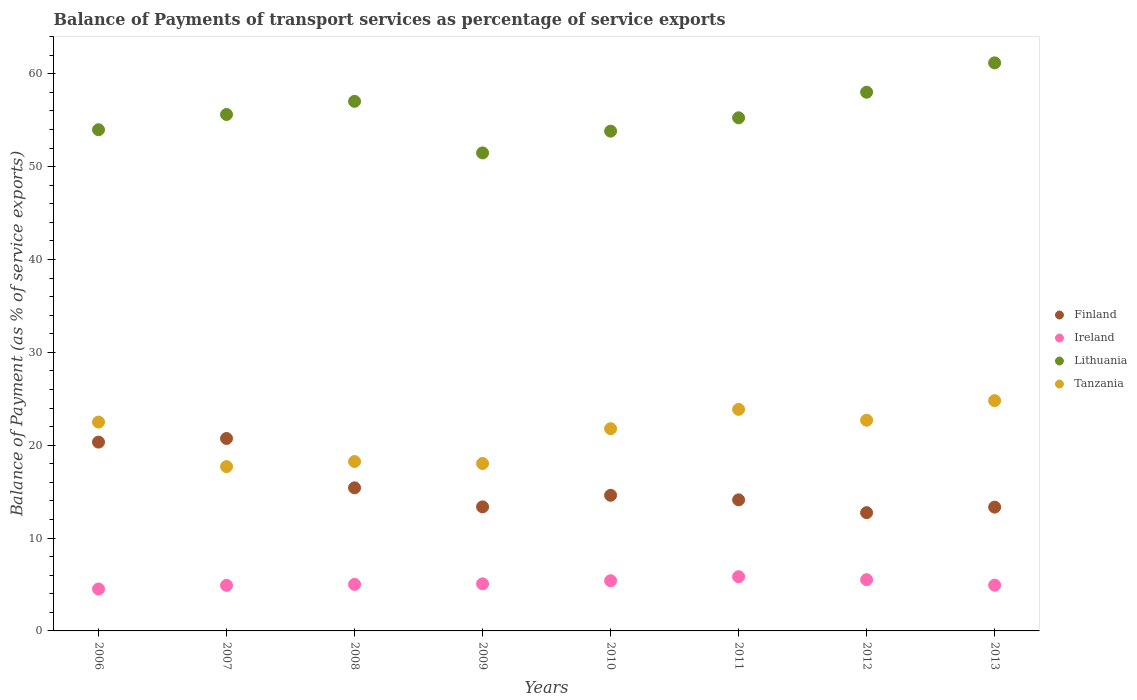How many different coloured dotlines are there?
Keep it short and to the point. 4. Is the number of dotlines equal to the number of legend labels?
Your response must be concise. Yes. What is the balance of payments of transport services in Finland in 2013?
Your answer should be very brief. 13.33. Across all years, what is the maximum balance of payments of transport services in Ireland?
Your answer should be compact. 5.84. Across all years, what is the minimum balance of payments of transport services in Finland?
Provide a succinct answer. 12.73. In which year was the balance of payments of transport services in Tanzania maximum?
Provide a succinct answer. 2013. What is the total balance of payments of transport services in Tanzania in the graph?
Your answer should be compact. 169.59. What is the difference between the balance of payments of transport services in Ireland in 2011 and that in 2013?
Ensure brevity in your answer.  0.91. What is the difference between the balance of payments of transport services in Finland in 2011 and the balance of payments of transport services in Tanzania in 2007?
Your response must be concise. -3.58. What is the average balance of payments of transport services in Finland per year?
Your response must be concise. 15.58. In the year 2007, what is the difference between the balance of payments of transport services in Finland and balance of payments of transport services in Ireland?
Offer a very short reply. 15.82. What is the ratio of the balance of payments of transport services in Ireland in 2007 to that in 2012?
Offer a terse response. 0.89. Is the difference between the balance of payments of transport services in Finland in 2008 and 2013 greater than the difference between the balance of payments of transport services in Ireland in 2008 and 2013?
Ensure brevity in your answer.  Yes. What is the difference between the highest and the second highest balance of payments of transport services in Tanzania?
Give a very brief answer. 0.94. What is the difference between the highest and the lowest balance of payments of transport services in Finland?
Your answer should be very brief. 7.99. How many dotlines are there?
Give a very brief answer. 4. What is the difference between two consecutive major ticks on the Y-axis?
Your answer should be compact. 10. Where does the legend appear in the graph?
Your answer should be very brief. Center right. What is the title of the graph?
Your response must be concise. Balance of Payments of transport services as percentage of service exports. What is the label or title of the X-axis?
Provide a succinct answer. Years. What is the label or title of the Y-axis?
Ensure brevity in your answer.  Balance of Payment (as % of service exports). What is the Balance of Payment (as % of service exports) of Finland in 2006?
Provide a short and direct response. 20.33. What is the Balance of Payment (as % of service exports) of Ireland in 2006?
Your answer should be compact. 4.52. What is the Balance of Payment (as % of service exports) in Lithuania in 2006?
Ensure brevity in your answer.  53.97. What is the Balance of Payment (as % of service exports) in Tanzania in 2006?
Provide a short and direct response. 22.49. What is the Balance of Payment (as % of service exports) in Finland in 2007?
Offer a terse response. 20.72. What is the Balance of Payment (as % of service exports) in Ireland in 2007?
Your response must be concise. 4.91. What is the Balance of Payment (as % of service exports) of Lithuania in 2007?
Ensure brevity in your answer.  55.62. What is the Balance of Payment (as % of service exports) in Tanzania in 2007?
Make the answer very short. 17.7. What is the Balance of Payment (as % of service exports) in Finland in 2008?
Provide a succinct answer. 15.41. What is the Balance of Payment (as % of service exports) of Ireland in 2008?
Give a very brief answer. 5.01. What is the Balance of Payment (as % of service exports) of Lithuania in 2008?
Make the answer very short. 57.03. What is the Balance of Payment (as % of service exports) of Tanzania in 2008?
Provide a succinct answer. 18.24. What is the Balance of Payment (as % of service exports) of Finland in 2009?
Keep it short and to the point. 13.36. What is the Balance of Payment (as % of service exports) in Ireland in 2009?
Your answer should be compact. 5.07. What is the Balance of Payment (as % of service exports) in Lithuania in 2009?
Provide a short and direct response. 51.48. What is the Balance of Payment (as % of service exports) of Tanzania in 2009?
Ensure brevity in your answer.  18.03. What is the Balance of Payment (as % of service exports) in Finland in 2010?
Your response must be concise. 14.61. What is the Balance of Payment (as % of service exports) of Ireland in 2010?
Your response must be concise. 5.4. What is the Balance of Payment (as % of service exports) in Lithuania in 2010?
Offer a terse response. 53.82. What is the Balance of Payment (as % of service exports) in Tanzania in 2010?
Keep it short and to the point. 21.78. What is the Balance of Payment (as % of service exports) in Finland in 2011?
Provide a succinct answer. 14.12. What is the Balance of Payment (as % of service exports) in Ireland in 2011?
Offer a terse response. 5.84. What is the Balance of Payment (as % of service exports) of Lithuania in 2011?
Provide a succinct answer. 55.26. What is the Balance of Payment (as % of service exports) in Tanzania in 2011?
Make the answer very short. 23.86. What is the Balance of Payment (as % of service exports) in Finland in 2012?
Give a very brief answer. 12.73. What is the Balance of Payment (as % of service exports) in Ireland in 2012?
Provide a succinct answer. 5.52. What is the Balance of Payment (as % of service exports) of Lithuania in 2012?
Provide a short and direct response. 58.01. What is the Balance of Payment (as % of service exports) of Tanzania in 2012?
Make the answer very short. 22.69. What is the Balance of Payment (as % of service exports) in Finland in 2013?
Ensure brevity in your answer.  13.33. What is the Balance of Payment (as % of service exports) in Ireland in 2013?
Your answer should be very brief. 4.93. What is the Balance of Payment (as % of service exports) in Lithuania in 2013?
Offer a terse response. 61.17. What is the Balance of Payment (as % of service exports) in Tanzania in 2013?
Ensure brevity in your answer.  24.8. Across all years, what is the maximum Balance of Payment (as % of service exports) of Finland?
Make the answer very short. 20.72. Across all years, what is the maximum Balance of Payment (as % of service exports) of Ireland?
Provide a short and direct response. 5.84. Across all years, what is the maximum Balance of Payment (as % of service exports) in Lithuania?
Your response must be concise. 61.17. Across all years, what is the maximum Balance of Payment (as % of service exports) in Tanzania?
Keep it short and to the point. 24.8. Across all years, what is the minimum Balance of Payment (as % of service exports) of Finland?
Your answer should be very brief. 12.73. Across all years, what is the minimum Balance of Payment (as % of service exports) in Ireland?
Offer a very short reply. 4.52. Across all years, what is the minimum Balance of Payment (as % of service exports) in Lithuania?
Your answer should be very brief. 51.48. Across all years, what is the minimum Balance of Payment (as % of service exports) of Tanzania?
Ensure brevity in your answer.  17.7. What is the total Balance of Payment (as % of service exports) of Finland in the graph?
Give a very brief answer. 124.62. What is the total Balance of Payment (as % of service exports) of Ireland in the graph?
Your answer should be compact. 41.2. What is the total Balance of Payment (as % of service exports) of Lithuania in the graph?
Provide a succinct answer. 446.37. What is the total Balance of Payment (as % of service exports) in Tanzania in the graph?
Your answer should be very brief. 169.59. What is the difference between the Balance of Payment (as % of service exports) of Finland in 2006 and that in 2007?
Provide a short and direct response. -0.39. What is the difference between the Balance of Payment (as % of service exports) in Ireland in 2006 and that in 2007?
Your response must be concise. -0.39. What is the difference between the Balance of Payment (as % of service exports) of Lithuania in 2006 and that in 2007?
Make the answer very short. -1.64. What is the difference between the Balance of Payment (as % of service exports) in Tanzania in 2006 and that in 2007?
Provide a short and direct response. 4.8. What is the difference between the Balance of Payment (as % of service exports) of Finland in 2006 and that in 2008?
Offer a very short reply. 4.92. What is the difference between the Balance of Payment (as % of service exports) in Ireland in 2006 and that in 2008?
Make the answer very short. -0.5. What is the difference between the Balance of Payment (as % of service exports) of Lithuania in 2006 and that in 2008?
Provide a succinct answer. -3.06. What is the difference between the Balance of Payment (as % of service exports) in Tanzania in 2006 and that in 2008?
Provide a succinct answer. 4.25. What is the difference between the Balance of Payment (as % of service exports) of Finland in 2006 and that in 2009?
Give a very brief answer. 6.98. What is the difference between the Balance of Payment (as % of service exports) in Ireland in 2006 and that in 2009?
Your answer should be compact. -0.56. What is the difference between the Balance of Payment (as % of service exports) of Lithuania in 2006 and that in 2009?
Ensure brevity in your answer.  2.5. What is the difference between the Balance of Payment (as % of service exports) of Tanzania in 2006 and that in 2009?
Provide a short and direct response. 4.46. What is the difference between the Balance of Payment (as % of service exports) of Finland in 2006 and that in 2010?
Offer a terse response. 5.73. What is the difference between the Balance of Payment (as % of service exports) in Ireland in 2006 and that in 2010?
Your answer should be very brief. -0.89. What is the difference between the Balance of Payment (as % of service exports) of Lithuania in 2006 and that in 2010?
Provide a short and direct response. 0.15. What is the difference between the Balance of Payment (as % of service exports) of Tanzania in 2006 and that in 2010?
Your answer should be compact. 0.72. What is the difference between the Balance of Payment (as % of service exports) in Finland in 2006 and that in 2011?
Your answer should be compact. 6.22. What is the difference between the Balance of Payment (as % of service exports) of Ireland in 2006 and that in 2011?
Your response must be concise. -1.33. What is the difference between the Balance of Payment (as % of service exports) of Lithuania in 2006 and that in 2011?
Your response must be concise. -1.29. What is the difference between the Balance of Payment (as % of service exports) in Tanzania in 2006 and that in 2011?
Provide a succinct answer. -1.37. What is the difference between the Balance of Payment (as % of service exports) in Finland in 2006 and that in 2012?
Your answer should be very brief. 7.6. What is the difference between the Balance of Payment (as % of service exports) of Ireland in 2006 and that in 2012?
Your answer should be compact. -1. What is the difference between the Balance of Payment (as % of service exports) of Lithuania in 2006 and that in 2012?
Ensure brevity in your answer.  -4.04. What is the difference between the Balance of Payment (as % of service exports) in Tanzania in 2006 and that in 2012?
Offer a terse response. -0.2. What is the difference between the Balance of Payment (as % of service exports) of Finland in 2006 and that in 2013?
Give a very brief answer. 7. What is the difference between the Balance of Payment (as % of service exports) in Ireland in 2006 and that in 2013?
Your answer should be very brief. -0.41. What is the difference between the Balance of Payment (as % of service exports) of Lithuania in 2006 and that in 2013?
Offer a very short reply. -7.2. What is the difference between the Balance of Payment (as % of service exports) of Tanzania in 2006 and that in 2013?
Make the answer very short. -2.3. What is the difference between the Balance of Payment (as % of service exports) in Finland in 2007 and that in 2008?
Your response must be concise. 5.31. What is the difference between the Balance of Payment (as % of service exports) of Ireland in 2007 and that in 2008?
Your response must be concise. -0.1. What is the difference between the Balance of Payment (as % of service exports) in Lithuania in 2007 and that in 2008?
Keep it short and to the point. -1.41. What is the difference between the Balance of Payment (as % of service exports) in Tanzania in 2007 and that in 2008?
Offer a very short reply. -0.55. What is the difference between the Balance of Payment (as % of service exports) in Finland in 2007 and that in 2009?
Offer a very short reply. 7.37. What is the difference between the Balance of Payment (as % of service exports) of Ireland in 2007 and that in 2009?
Ensure brevity in your answer.  -0.16. What is the difference between the Balance of Payment (as % of service exports) of Lithuania in 2007 and that in 2009?
Your answer should be compact. 4.14. What is the difference between the Balance of Payment (as % of service exports) in Tanzania in 2007 and that in 2009?
Make the answer very short. -0.33. What is the difference between the Balance of Payment (as % of service exports) in Finland in 2007 and that in 2010?
Your answer should be very brief. 6.12. What is the difference between the Balance of Payment (as % of service exports) in Ireland in 2007 and that in 2010?
Provide a short and direct response. -0.5. What is the difference between the Balance of Payment (as % of service exports) of Lithuania in 2007 and that in 2010?
Your answer should be compact. 1.79. What is the difference between the Balance of Payment (as % of service exports) in Tanzania in 2007 and that in 2010?
Offer a very short reply. -4.08. What is the difference between the Balance of Payment (as % of service exports) in Finland in 2007 and that in 2011?
Your response must be concise. 6.61. What is the difference between the Balance of Payment (as % of service exports) in Ireland in 2007 and that in 2011?
Your response must be concise. -0.93. What is the difference between the Balance of Payment (as % of service exports) in Lithuania in 2007 and that in 2011?
Offer a terse response. 0.36. What is the difference between the Balance of Payment (as % of service exports) in Tanzania in 2007 and that in 2011?
Your answer should be very brief. -6.16. What is the difference between the Balance of Payment (as % of service exports) in Finland in 2007 and that in 2012?
Give a very brief answer. 7.99. What is the difference between the Balance of Payment (as % of service exports) in Ireland in 2007 and that in 2012?
Provide a succinct answer. -0.61. What is the difference between the Balance of Payment (as % of service exports) in Lithuania in 2007 and that in 2012?
Provide a short and direct response. -2.4. What is the difference between the Balance of Payment (as % of service exports) in Tanzania in 2007 and that in 2012?
Offer a terse response. -4.99. What is the difference between the Balance of Payment (as % of service exports) of Finland in 2007 and that in 2013?
Ensure brevity in your answer.  7.39. What is the difference between the Balance of Payment (as % of service exports) in Ireland in 2007 and that in 2013?
Your response must be concise. -0.02. What is the difference between the Balance of Payment (as % of service exports) of Lithuania in 2007 and that in 2013?
Provide a succinct answer. -5.56. What is the difference between the Balance of Payment (as % of service exports) in Tanzania in 2007 and that in 2013?
Offer a terse response. -7.1. What is the difference between the Balance of Payment (as % of service exports) of Finland in 2008 and that in 2009?
Keep it short and to the point. 2.05. What is the difference between the Balance of Payment (as % of service exports) in Ireland in 2008 and that in 2009?
Your answer should be compact. -0.06. What is the difference between the Balance of Payment (as % of service exports) in Lithuania in 2008 and that in 2009?
Give a very brief answer. 5.56. What is the difference between the Balance of Payment (as % of service exports) in Tanzania in 2008 and that in 2009?
Your answer should be very brief. 0.21. What is the difference between the Balance of Payment (as % of service exports) of Finland in 2008 and that in 2010?
Your response must be concise. 0.8. What is the difference between the Balance of Payment (as % of service exports) in Ireland in 2008 and that in 2010?
Provide a succinct answer. -0.39. What is the difference between the Balance of Payment (as % of service exports) of Lithuania in 2008 and that in 2010?
Ensure brevity in your answer.  3.21. What is the difference between the Balance of Payment (as % of service exports) in Tanzania in 2008 and that in 2010?
Offer a very short reply. -3.53. What is the difference between the Balance of Payment (as % of service exports) in Finland in 2008 and that in 2011?
Provide a succinct answer. 1.29. What is the difference between the Balance of Payment (as % of service exports) of Ireland in 2008 and that in 2011?
Make the answer very short. -0.83. What is the difference between the Balance of Payment (as % of service exports) in Lithuania in 2008 and that in 2011?
Make the answer very short. 1.77. What is the difference between the Balance of Payment (as % of service exports) of Tanzania in 2008 and that in 2011?
Keep it short and to the point. -5.62. What is the difference between the Balance of Payment (as % of service exports) of Finland in 2008 and that in 2012?
Your answer should be very brief. 2.68. What is the difference between the Balance of Payment (as % of service exports) in Ireland in 2008 and that in 2012?
Offer a terse response. -0.51. What is the difference between the Balance of Payment (as % of service exports) of Lithuania in 2008 and that in 2012?
Provide a short and direct response. -0.98. What is the difference between the Balance of Payment (as % of service exports) in Tanzania in 2008 and that in 2012?
Provide a succinct answer. -4.45. What is the difference between the Balance of Payment (as % of service exports) in Finland in 2008 and that in 2013?
Your answer should be very brief. 2.08. What is the difference between the Balance of Payment (as % of service exports) of Ireland in 2008 and that in 2013?
Your response must be concise. 0.09. What is the difference between the Balance of Payment (as % of service exports) in Lithuania in 2008 and that in 2013?
Your answer should be compact. -4.14. What is the difference between the Balance of Payment (as % of service exports) in Tanzania in 2008 and that in 2013?
Provide a succinct answer. -6.55. What is the difference between the Balance of Payment (as % of service exports) of Finland in 2009 and that in 2010?
Keep it short and to the point. -1.25. What is the difference between the Balance of Payment (as % of service exports) in Ireland in 2009 and that in 2010?
Provide a succinct answer. -0.33. What is the difference between the Balance of Payment (as % of service exports) in Lithuania in 2009 and that in 2010?
Make the answer very short. -2.35. What is the difference between the Balance of Payment (as % of service exports) in Tanzania in 2009 and that in 2010?
Provide a succinct answer. -3.75. What is the difference between the Balance of Payment (as % of service exports) of Finland in 2009 and that in 2011?
Provide a short and direct response. -0.76. What is the difference between the Balance of Payment (as % of service exports) in Ireland in 2009 and that in 2011?
Offer a terse response. -0.77. What is the difference between the Balance of Payment (as % of service exports) in Lithuania in 2009 and that in 2011?
Offer a terse response. -3.78. What is the difference between the Balance of Payment (as % of service exports) of Tanzania in 2009 and that in 2011?
Your response must be concise. -5.83. What is the difference between the Balance of Payment (as % of service exports) in Finland in 2009 and that in 2012?
Offer a terse response. 0.62. What is the difference between the Balance of Payment (as % of service exports) in Ireland in 2009 and that in 2012?
Your answer should be very brief. -0.45. What is the difference between the Balance of Payment (as % of service exports) in Lithuania in 2009 and that in 2012?
Your answer should be very brief. -6.54. What is the difference between the Balance of Payment (as % of service exports) of Tanzania in 2009 and that in 2012?
Keep it short and to the point. -4.66. What is the difference between the Balance of Payment (as % of service exports) in Finland in 2009 and that in 2013?
Ensure brevity in your answer.  0.03. What is the difference between the Balance of Payment (as % of service exports) in Ireland in 2009 and that in 2013?
Your response must be concise. 0.14. What is the difference between the Balance of Payment (as % of service exports) in Lithuania in 2009 and that in 2013?
Provide a succinct answer. -9.7. What is the difference between the Balance of Payment (as % of service exports) of Tanzania in 2009 and that in 2013?
Your answer should be very brief. -6.77. What is the difference between the Balance of Payment (as % of service exports) in Finland in 2010 and that in 2011?
Provide a short and direct response. 0.49. What is the difference between the Balance of Payment (as % of service exports) of Ireland in 2010 and that in 2011?
Offer a very short reply. -0.44. What is the difference between the Balance of Payment (as % of service exports) in Lithuania in 2010 and that in 2011?
Ensure brevity in your answer.  -1.44. What is the difference between the Balance of Payment (as % of service exports) in Tanzania in 2010 and that in 2011?
Give a very brief answer. -2.08. What is the difference between the Balance of Payment (as % of service exports) of Finland in 2010 and that in 2012?
Provide a succinct answer. 1.87. What is the difference between the Balance of Payment (as % of service exports) in Ireland in 2010 and that in 2012?
Your answer should be very brief. -0.11. What is the difference between the Balance of Payment (as % of service exports) of Lithuania in 2010 and that in 2012?
Keep it short and to the point. -4.19. What is the difference between the Balance of Payment (as % of service exports) in Tanzania in 2010 and that in 2012?
Keep it short and to the point. -0.91. What is the difference between the Balance of Payment (as % of service exports) in Finland in 2010 and that in 2013?
Your answer should be very brief. 1.28. What is the difference between the Balance of Payment (as % of service exports) of Ireland in 2010 and that in 2013?
Make the answer very short. 0.48. What is the difference between the Balance of Payment (as % of service exports) of Lithuania in 2010 and that in 2013?
Offer a very short reply. -7.35. What is the difference between the Balance of Payment (as % of service exports) of Tanzania in 2010 and that in 2013?
Your response must be concise. -3.02. What is the difference between the Balance of Payment (as % of service exports) of Finland in 2011 and that in 2012?
Provide a succinct answer. 1.38. What is the difference between the Balance of Payment (as % of service exports) of Ireland in 2011 and that in 2012?
Provide a short and direct response. 0.32. What is the difference between the Balance of Payment (as % of service exports) of Lithuania in 2011 and that in 2012?
Offer a terse response. -2.76. What is the difference between the Balance of Payment (as % of service exports) of Tanzania in 2011 and that in 2012?
Offer a very short reply. 1.17. What is the difference between the Balance of Payment (as % of service exports) in Finland in 2011 and that in 2013?
Provide a short and direct response. 0.78. What is the difference between the Balance of Payment (as % of service exports) in Ireland in 2011 and that in 2013?
Make the answer very short. 0.91. What is the difference between the Balance of Payment (as % of service exports) in Lithuania in 2011 and that in 2013?
Offer a very short reply. -5.91. What is the difference between the Balance of Payment (as % of service exports) of Tanzania in 2011 and that in 2013?
Provide a short and direct response. -0.94. What is the difference between the Balance of Payment (as % of service exports) in Finland in 2012 and that in 2013?
Give a very brief answer. -0.6. What is the difference between the Balance of Payment (as % of service exports) of Ireland in 2012 and that in 2013?
Your answer should be compact. 0.59. What is the difference between the Balance of Payment (as % of service exports) of Lithuania in 2012 and that in 2013?
Provide a succinct answer. -3.16. What is the difference between the Balance of Payment (as % of service exports) in Tanzania in 2012 and that in 2013?
Keep it short and to the point. -2.11. What is the difference between the Balance of Payment (as % of service exports) in Finland in 2006 and the Balance of Payment (as % of service exports) in Ireland in 2007?
Offer a terse response. 15.43. What is the difference between the Balance of Payment (as % of service exports) of Finland in 2006 and the Balance of Payment (as % of service exports) of Lithuania in 2007?
Your answer should be very brief. -35.28. What is the difference between the Balance of Payment (as % of service exports) of Finland in 2006 and the Balance of Payment (as % of service exports) of Tanzania in 2007?
Make the answer very short. 2.64. What is the difference between the Balance of Payment (as % of service exports) of Ireland in 2006 and the Balance of Payment (as % of service exports) of Lithuania in 2007?
Provide a short and direct response. -51.1. What is the difference between the Balance of Payment (as % of service exports) of Ireland in 2006 and the Balance of Payment (as % of service exports) of Tanzania in 2007?
Offer a terse response. -13.18. What is the difference between the Balance of Payment (as % of service exports) of Lithuania in 2006 and the Balance of Payment (as % of service exports) of Tanzania in 2007?
Provide a short and direct response. 36.28. What is the difference between the Balance of Payment (as % of service exports) of Finland in 2006 and the Balance of Payment (as % of service exports) of Ireland in 2008?
Give a very brief answer. 15.32. What is the difference between the Balance of Payment (as % of service exports) of Finland in 2006 and the Balance of Payment (as % of service exports) of Lithuania in 2008?
Offer a very short reply. -36.7. What is the difference between the Balance of Payment (as % of service exports) of Finland in 2006 and the Balance of Payment (as % of service exports) of Tanzania in 2008?
Make the answer very short. 2.09. What is the difference between the Balance of Payment (as % of service exports) in Ireland in 2006 and the Balance of Payment (as % of service exports) in Lithuania in 2008?
Give a very brief answer. -52.52. What is the difference between the Balance of Payment (as % of service exports) in Ireland in 2006 and the Balance of Payment (as % of service exports) in Tanzania in 2008?
Your answer should be compact. -13.73. What is the difference between the Balance of Payment (as % of service exports) of Lithuania in 2006 and the Balance of Payment (as % of service exports) of Tanzania in 2008?
Make the answer very short. 35.73. What is the difference between the Balance of Payment (as % of service exports) in Finland in 2006 and the Balance of Payment (as % of service exports) in Ireland in 2009?
Offer a very short reply. 15.26. What is the difference between the Balance of Payment (as % of service exports) of Finland in 2006 and the Balance of Payment (as % of service exports) of Lithuania in 2009?
Your answer should be very brief. -31.14. What is the difference between the Balance of Payment (as % of service exports) of Finland in 2006 and the Balance of Payment (as % of service exports) of Tanzania in 2009?
Offer a very short reply. 2.3. What is the difference between the Balance of Payment (as % of service exports) of Ireland in 2006 and the Balance of Payment (as % of service exports) of Lithuania in 2009?
Your answer should be very brief. -46.96. What is the difference between the Balance of Payment (as % of service exports) of Ireland in 2006 and the Balance of Payment (as % of service exports) of Tanzania in 2009?
Offer a very short reply. -13.52. What is the difference between the Balance of Payment (as % of service exports) in Lithuania in 2006 and the Balance of Payment (as % of service exports) in Tanzania in 2009?
Make the answer very short. 35.94. What is the difference between the Balance of Payment (as % of service exports) in Finland in 2006 and the Balance of Payment (as % of service exports) in Ireland in 2010?
Give a very brief answer. 14.93. What is the difference between the Balance of Payment (as % of service exports) in Finland in 2006 and the Balance of Payment (as % of service exports) in Lithuania in 2010?
Keep it short and to the point. -33.49. What is the difference between the Balance of Payment (as % of service exports) of Finland in 2006 and the Balance of Payment (as % of service exports) of Tanzania in 2010?
Your answer should be compact. -1.44. What is the difference between the Balance of Payment (as % of service exports) of Ireland in 2006 and the Balance of Payment (as % of service exports) of Lithuania in 2010?
Offer a very short reply. -49.31. What is the difference between the Balance of Payment (as % of service exports) in Ireland in 2006 and the Balance of Payment (as % of service exports) in Tanzania in 2010?
Make the answer very short. -17.26. What is the difference between the Balance of Payment (as % of service exports) in Lithuania in 2006 and the Balance of Payment (as % of service exports) in Tanzania in 2010?
Keep it short and to the point. 32.2. What is the difference between the Balance of Payment (as % of service exports) of Finland in 2006 and the Balance of Payment (as % of service exports) of Ireland in 2011?
Provide a short and direct response. 14.49. What is the difference between the Balance of Payment (as % of service exports) of Finland in 2006 and the Balance of Payment (as % of service exports) of Lithuania in 2011?
Give a very brief answer. -34.92. What is the difference between the Balance of Payment (as % of service exports) of Finland in 2006 and the Balance of Payment (as % of service exports) of Tanzania in 2011?
Make the answer very short. -3.52. What is the difference between the Balance of Payment (as % of service exports) of Ireland in 2006 and the Balance of Payment (as % of service exports) of Lithuania in 2011?
Keep it short and to the point. -50.74. What is the difference between the Balance of Payment (as % of service exports) of Ireland in 2006 and the Balance of Payment (as % of service exports) of Tanzania in 2011?
Your answer should be very brief. -19.34. What is the difference between the Balance of Payment (as % of service exports) in Lithuania in 2006 and the Balance of Payment (as % of service exports) in Tanzania in 2011?
Your answer should be very brief. 30.11. What is the difference between the Balance of Payment (as % of service exports) in Finland in 2006 and the Balance of Payment (as % of service exports) in Ireland in 2012?
Your answer should be compact. 14.82. What is the difference between the Balance of Payment (as % of service exports) of Finland in 2006 and the Balance of Payment (as % of service exports) of Lithuania in 2012?
Make the answer very short. -37.68. What is the difference between the Balance of Payment (as % of service exports) of Finland in 2006 and the Balance of Payment (as % of service exports) of Tanzania in 2012?
Your answer should be compact. -2.36. What is the difference between the Balance of Payment (as % of service exports) of Ireland in 2006 and the Balance of Payment (as % of service exports) of Lithuania in 2012?
Provide a succinct answer. -53.5. What is the difference between the Balance of Payment (as % of service exports) in Ireland in 2006 and the Balance of Payment (as % of service exports) in Tanzania in 2012?
Provide a short and direct response. -18.18. What is the difference between the Balance of Payment (as % of service exports) in Lithuania in 2006 and the Balance of Payment (as % of service exports) in Tanzania in 2012?
Your answer should be very brief. 31.28. What is the difference between the Balance of Payment (as % of service exports) in Finland in 2006 and the Balance of Payment (as % of service exports) in Ireland in 2013?
Offer a terse response. 15.41. What is the difference between the Balance of Payment (as % of service exports) of Finland in 2006 and the Balance of Payment (as % of service exports) of Lithuania in 2013?
Offer a terse response. -40.84. What is the difference between the Balance of Payment (as % of service exports) in Finland in 2006 and the Balance of Payment (as % of service exports) in Tanzania in 2013?
Offer a very short reply. -4.46. What is the difference between the Balance of Payment (as % of service exports) in Ireland in 2006 and the Balance of Payment (as % of service exports) in Lithuania in 2013?
Provide a succinct answer. -56.66. What is the difference between the Balance of Payment (as % of service exports) in Ireland in 2006 and the Balance of Payment (as % of service exports) in Tanzania in 2013?
Give a very brief answer. -20.28. What is the difference between the Balance of Payment (as % of service exports) of Lithuania in 2006 and the Balance of Payment (as % of service exports) of Tanzania in 2013?
Your response must be concise. 29.18. What is the difference between the Balance of Payment (as % of service exports) of Finland in 2007 and the Balance of Payment (as % of service exports) of Ireland in 2008?
Provide a succinct answer. 15.71. What is the difference between the Balance of Payment (as % of service exports) of Finland in 2007 and the Balance of Payment (as % of service exports) of Lithuania in 2008?
Provide a short and direct response. -36.31. What is the difference between the Balance of Payment (as % of service exports) in Finland in 2007 and the Balance of Payment (as % of service exports) in Tanzania in 2008?
Your response must be concise. 2.48. What is the difference between the Balance of Payment (as % of service exports) of Ireland in 2007 and the Balance of Payment (as % of service exports) of Lithuania in 2008?
Keep it short and to the point. -52.12. What is the difference between the Balance of Payment (as % of service exports) in Ireland in 2007 and the Balance of Payment (as % of service exports) in Tanzania in 2008?
Provide a succinct answer. -13.33. What is the difference between the Balance of Payment (as % of service exports) in Lithuania in 2007 and the Balance of Payment (as % of service exports) in Tanzania in 2008?
Offer a very short reply. 37.37. What is the difference between the Balance of Payment (as % of service exports) in Finland in 2007 and the Balance of Payment (as % of service exports) in Ireland in 2009?
Your response must be concise. 15.65. What is the difference between the Balance of Payment (as % of service exports) of Finland in 2007 and the Balance of Payment (as % of service exports) of Lithuania in 2009?
Give a very brief answer. -30.75. What is the difference between the Balance of Payment (as % of service exports) of Finland in 2007 and the Balance of Payment (as % of service exports) of Tanzania in 2009?
Give a very brief answer. 2.69. What is the difference between the Balance of Payment (as % of service exports) of Ireland in 2007 and the Balance of Payment (as % of service exports) of Lithuania in 2009?
Provide a succinct answer. -46.57. What is the difference between the Balance of Payment (as % of service exports) in Ireland in 2007 and the Balance of Payment (as % of service exports) in Tanzania in 2009?
Your answer should be very brief. -13.12. What is the difference between the Balance of Payment (as % of service exports) in Lithuania in 2007 and the Balance of Payment (as % of service exports) in Tanzania in 2009?
Offer a very short reply. 37.59. What is the difference between the Balance of Payment (as % of service exports) in Finland in 2007 and the Balance of Payment (as % of service exports) in Ireland in 2010?
Your answer should be compact. 15.32. What is the difference between the Balance of Payment (as % of service exports) of Finland in 2007 and the Balance of Payment (as % of service exports) of Lithuania in 2010?
Provide a short and direct response. -33.1. What is the difference between the Balance of Payment (as % of service exports) in Finland in 2007 and the Balance of Payment (as % of service exports) in Tanzania in 2010?
Provide a succinct answer. -1.05. What is the difference between the Balance of Payment (as % of service exports) in Ireland in 2007 and the Balance of Payment (as % of service exports) in Lithuania in 2010?
Ensure brevity in your answer.  -48.91. What is the difference between the Balance of Payment (as % of service exports) of Ireland in 2007 and the Balance of Payment (as % of service exports) of Tanzania in 2010?
Offer a very short reply. -16.87. What is the difference between the Balance of Payment (as % of service exports) of Lithuania in 2007 and the Balance of Payment (as % of service exports) of Tanzania in 2010?
Your answer should be very brief. 33.84. What is the difference between the Balance of Payment (as % of service exports) in Finland in 2007 and the Balance of Payment (as % of service exports) in Ireland in 2011?
Your response must be concise. 14.88. What is the difference between the Balance of Payment (as % of service exports) of Finland in 2007 and the Balance of Payment (as % of service exports) of Lithuania in 2011?
Your answer should be very brief. -34.53. What is the difference between the Balance of Payment (as % of service exports) of Finland in 2007 and the Balance of Payment (as % of service exports) of Tanzania in 2011?
Your answer should be very brief. -3.13. What is the difference between the Balance of Payment (as % of service exports) of Ireland in 2007 and the Balance of Payment (as % of service exports) of Lithuania in 2011?
Provide a succinct answer. -50.35. What is the difference between the Balance of Payment (as % of service exports) in Ireland in 2007 and the Balance of Payment (as % of service exports) in Tanzania in 2011?
Make the answer very short. -18.95. What is the difference between the Balance of Payment (as % of service exports) of Lithuania in 2007 and the Balance of Payment (as % of service exports) of Tanzania in 2011?
Your answer should be compact. 31.76. What is the difference between the Balance of Payment (as % of service exports) of Finland in 2007 and the Balance of Payment (as % of service exports) of Ireland in 2012?
Provide a succinct answer. 15.21. What is the difference between the Balance of Payment (as % of service exports) of Finland in 2007 and the Balance of Payment (as % of service exports) of Lithuania in 2012?
Your answer should be very brief. -37.29. What is the difference between the Balance of Payment (as % of service exports) in Finland in 2007 and the Balance of Payment (as % of service exports) in Tanzania in 2012?
Give a very brief answer. -1.97. What is the difference between the Balance of Payment (as % of service exports) of Ireland in 2007 and the Balance of Payment (as % of service exports) of Lithuania in 2012?
Provide a short and direct response. -53.11. What is the difference between the Balance of Payment (as % of service exports) of Ireland in 2007 and the Balance of Payment (as % of service exports) of Tanzania in 2012?
Provide a short and direct response. -17.78. What is the difference between the Balance of Payment (as % of service exports) in Lithuania in 2007 and the Balance of Payment (as % of service exports) in Tanzania in 2012?
Ensure brevity in your answer.  32.93. What is the difference between the Balance of Payment (as % of service exports) in Finland in 2007 and the Balance of Payment (as % of service exports) in Ireland in 2013?
Provide a succinct answer. 15.8. What is the difference between the Balance of Payment (as % of service exports) in Finland in 2007 and the Balance of Payment (as % of service exports) in Lithuania in 2013?
Your response must be concise. -40.45. What is the difference between the Balance of Payment (as % of service exports) in Finland in 2007 and the Balance of Payment (as % of service exports) in Tanzania in 2013?
Provide a short and direct response. -4.07. What is the difference between the Balance of Payment (as % of service exports) in Ireland in 2007 and the Balance of Payment (as % of service exports) in Lithuania in 2013?
Ensure brevity in your answer.  -56.26. What is the difference between the Balance of Payment (as % of service exports) in Ireland in 2007 and the Balance of Payment (as % of service exports) in Tanzania in 2013?
Make the answer very short. -19.89. What is the difference between the Balance of Payment (as % of service exports) of Lithuania in 2007 and the Balance of Payment (as % of service exports) of Tanzania in 2013?
Offer a terse response. 30.82. What is the difference between the Balance of Payment (as % of service exports) in Finland in 2008 and the Balance of Payment (as % of service exports) in Ireland in 2009?
Provide a succinct answer. 10.34. What is the difference between the Balance of Payment (as % of service exports) in Finland in 2008 and the Balance of Payment (as % of service exports) in Lithuania in 2009?
Give a very brief answer. -36.07. What is the difference between the Balance of Payment (as % of service exports) of Finland in 2008 and the Balance of Payment (as % of service exports) of Tanzania in 2009?
Offer a very short reply. -2.62. What is the difference between the Balance of Payment (as % of service exports) in Ireland in 2008 and the Balance of Payment (as % of service exports) in Lithuania in 2009?
Your answer should be very brief. -46.46. What is the difference between the Balance of Payment (as % of service exports) in Ireland in 2008 and the Balance of Payment (as % of service exports) in Tanzania in 2009?
Provide a short and direct response. -13.02. What is the difference between the Balance of Payment (as % of service exports) of Lithuania in 2008 and the Balance of Payment (as % of service exports) of Tanzania in 2009?
Your answer should be very brief. 39. What is the difference between the Balance of Payment (as % of service exports) in Finland in 2008 and the Balance of Payment (as % of service exports) in Ireland in 2010?
Ensure brevity in your answer.  10.01. What is the difference between the Balance of Payment (as % of service exports) of Finland in 2008 and the Balance of Payment (as % of service exports) of Lithuania in 2010?
Give a very brief answer. -38.41. What is the difference between the Balance of Payment (as % of service exports) of Finland in 2008 and the Balance of Payment (as % of service exports) of Tanzania in 2010?
Provide a succinct answer. -6.37. What is the difference between the Balance of Payment (as % of service exports) of Ireland in 2008 and the Balance of Payment (as % of service exports) of Lithuania in 2010?
Provide a succinct answer. -48.81. What is the difference between the Balance of Payment (as % of service exports) of Ireland in 2008 and the Balance of Payment (as % of service exports) of Tanzania in 2010?
Give a very brief answer. -16.77. What is the difference between the Balance of Payment (as % of service exports) of Lithuania in 2008 and the Balance of Payment (as % of service exports) of Tanzania in 2010?
Offer a very short reply. 35.25. What is the difference between the Balance of Payment (as % of service exports) of Finland in 2008 and the Balance of Payment (as % of service exports) of Ireland in 2011?
Make the answer very short. 9.57. What is the difference between the Balance of Payment (as % of service exports) in Finland in 2008 and the Balance of Payment (as % of service exports) in Lithuania in 2011?
Provide a succinct answer. -39.85. What is the difference between the Balance of Payment (as % of service exports) of Finland in 2008 and the Balance of Payment (as % of service exports) of Tanzania in 2011?
Your response must be concise. -8.45. What is the difference between the Balance of Payment (as % of service exports) in Ireland in 2008 and the Balance of Payment (as % of service exports) in Lithuania in 2011?
Give a very brief answer. -50.25. What is the difference between the Balance of Payment (as % of service exports) of Ireland in 2008 and the Balance of Payment (as % of service exports) of Tanzania in 2011?
Offer a very short reply. -18.85. What is the difference between the Balance of Payment (as % of service exports) of Lithuania in 2008 and the Balance of Payment (as % of service exports) of Tanzania in 2011?
Your answer should be compact. 33.17. What is the difference between the Balance of Payment (as % of service exports) of Finland in 2008 and the Balance of Payment (as % of service exports) of Ireland in 2012?
Provide a short and direct response. 9.89. What is the difference between the Balance of Payment (as % of service exports) of Finland in 2008 and the Balance of Payment (as % of service exports) of Lithuania in 2012?
Make the answer very short. -42.6. What is the difference between the Balance of Payment (as % of service exports) of Finland in 2008 and the Balance of Payment (as % of service exports) of Tanzania in 2012?
Offer a very short reply. -7.28. What is the difference between the Balance of Payment (as % of service exports) of Ireland in 2008 and the Balance of Payment (as % of service exports) of Lithuania in 2012?
Give a very brief answer. -53. What is the difference between the Balance of Payment (as % of service exports) of Ireland in 2008 and the Balance of Payment (as % of service exports) of Tanzania in 2012?
Offer a terse response. -17.68. What is the difference between the Balance of Payment (as % of service exports) in Lithuania in 2008 and the Balance of Payment (as % of service exports) in Tanzania in 2012?
Offer a terse response. 34.34. What is the difference between the Balance of Payment (as % of service exports) of Finland in 2008 and the Balance of Payment (as % of service exports) of Ireland in 2013?
Provide a succinct answer. 10.48. What is the difference between the Balance of Payment (as % of service exports) of Finland in 2008 and the Balance of Payment (as % of service exports) of Lithuania in 2013?
Keep it short and to the point. -45.76. What is the difference between the Balance of Payment (as % of service exports) of Finland in 2008 and the Balance of Payment (as % of service exports) of Tanzania in 2013?
Offer a terse response. -9.39. What is the difference between the Balance of Payment (as % of service exports) of Ireland in 2008 and the Balance of Payment (as % of service exports) of Lithuania in 2013?
Keep it short and to the point. -56.16. What is the difference between the Balance of Payment (as % of service exports) in Ireland in 2008 and the Balance of Payment (as % of service exports) in Tanzania in 2013?
Give a very brief answer. -19.78. What is the difference between the Balance of Payment (as % of service exports) of Lithuania in 2008 and the Balance of Payment (as % of service exports) of Tanzania in 2013?
Offer a very short reply. 32.23. What is the difference between the Balance of Payment (as % of service exports) in Finland in 2009 and the Balance of Payment (as % of service exports) in Ireland in 2010?
Your answer should be compact. 7.95. What is the difference between the Balance of Payment (as % of service exports) of Finland in 2009 and the Balance of Payment (as % of service exports) of Lithuania in 2010?
Your answer should be compact. -40.46. What is the difference between the Balance of Payment (as % of service exports) of Finland in 2009 and the Balance of Payment (as % of service exports) of Tanzania in 2010?
Your answer should be compact. -8.42. What is the difference between the Balance of Payment (as % of service exports) in Ireland in 2009 and the Balance of Payment (as % of service exports) in Lithuania in 2010?
Provide a succinct answer. -48.75. What is the difference between the Balance of Payment (as % of service exports) in Ireland in 2009 and the Balance of Payment (as % of service exports) in Tanzania in 2010?
Provide a short and direct response. -16.71. What is the difference between the Balance of Payment (as % of service exports) of Lithuania in 2009 and the Balance of Payment (as % of service exports) of Tanzania in 2010?
Your response must be concise. 29.7. What is the difference between the Balance of Payment (as % of service exports) in Finland in 2009 and the Balance of Payment (as % of service exports) in Ireland in 2011?
Keep it short and to the point. 7.52. What is the difference between the Balance of Payment (as % of service exports) in Finland in 2009 and the Balance of Payment (as % of service exports) in Lithuania in 2011?
Offer a very short reply. -41.9. What is the difference between the Balance of Payment (as % of service exports) in Finland in 2009 and the Balance of Payment (as % of service exports) in Tanzania in 2011?
Give a very brief answer. -10.5. What is the difference between the Balance of Payment (as % of service exports) of Ireland in 2009 and the Balance of Payment (as % of service exports) of Lithuania in 2011?
Give a very brief answer. -50.19. What is the difference between the Balance of Payment (as % of service exports) in Ireland in 2009 and the Balance of Payment (as % of service exports) in Tanzania in 2011?
Offer a terse response. -18.79. What is the difference between the Balance of Payment (as % of service exports) in Lithuania in 2009 and the Balance of Payment (as % of service exports) in Tanzania in 2011?
Offer a terse response. 27.62. What is the difference between the Balance of Payment (as % of service exports) in Finland in 2009 and the Balance of Payment (as % of service exports) in Ireland in 2012?
Give a very brief answer. 7.84. What is the difference between the Balance of Payment (as % of service exports) of Finland in 2009 and the Balance of Payment (as % of service exports) of Lithuania in 2012?
Offer a terse response. -44.65. What is the difference between the Balance of Payment (as % of service exports) in Finland in 2009 and the Balance of Payment (as % of service exports) in Tanzania in 2012?
Provide a succinct answer. -9.33. What is the difference between the Balance of Payment (as % of service exports) in Ireland in 2009 and the Balance of Payment (as % of service exports) in Lithuania in 2012?
Provide a short and direct response. -52.94. What is the difference between the Balance of Payment (as % of service exports) of Ireland in 2009 and the Balance of Payment (as % of service exports) of Tanzania in 2012?
Provide a short and direct response. -17.62. What is the difference between the Balance of Payment (as % of service exports) of Lithuania in 2009 and the Balance of Payment (as % of service exports) of Tanzania in 2012?
Your answer should be compact. 28.79. What is the difference between the Balance of Payment (as % of service exports) of Finland in 2009 and the Balance of Payment (as % of service exports) of Ireland in 2013?
Ensure brevity in your answer.  8.43. What is the difference between the Balance of Payment (as % of service exports) in Finland in 2009 and the Balance of Payment (as % of service exports) in Lithuania in 2013?
Provide a succinct answer. -47.81. What is the difference between the Balance of Payment (as % of service exports) in Finland in 2009 and the Balance of Payment (as % of service exports) in Tanzania in 2013?
Give a very brief answer. -11.44. What is the difference between the Balance of Payment (as % of service exports) in Ireland in 2009 and the Balance of Payment (as % of service exports) in Lithuania in 2013?
Ensure brevity in your answer.  -56.1. What is the difference between the Balance of Payment (as % of service exports) in Ireland in 2009 and the Balance of Payment (as % of service exports) in Tanzania in 2013?
Give a very brief answer. -19.73. What is the difference between the Balance of Payment (as % of service exports) in Lithuania in 2009 and the Balance of Payment (as % of service exports) in Tanzania in 2013?
Ensure brevity in your answer.  26.68. What is the difference between the Balance of Payment (as % of service exports) in Finland in 2010 and the Balance of Payment (as % of service exports) in Ireland in 2011?
Offer a very short reply. 8.77. What is the difference between the Balance of Payment (as % of service exports) of Finland in 2010 and the Balance of Payment (as % of service exports) of Lithuania in 2011?
Offer a very short reply. -40.65. What is the difference between the Balance of Payment (as % of service exports) in Finland in 2010 and the Balance of Payment (as % of service exports) in Tanzania in 2011?
Your response must be concise. -9.25. What is the difference between the Balance of Payment (as % of service exports) of Ireland in 2010 and the Balance of Payment (as % of service exports) of Lithuania in 2011?
Ensure brevity in your answer.  -49.85. What is the difference between the Balance of Payment (as % of service exports) of Ireland in 2010 and the Balance of Payment (as % of service exports) of Tanzania in 2011?
Make the answer very short. -18.45. What is the difference between the Balance of Payment (as % of service exports) in Lithuania in 2010 and the Balance of Payment (as % of service exports) in Tanzania in 2011?
Provide a short and direct response. 29.96. What is the difference between the Balance of Payment (as % of service exports) of Finland in 2010 and the Balance of Payment (as % of service exports) of Ireland in 2012?
Offer a terse response. 9.09. What is the difference between the Balance of Payment (as % of service exports) in Finland in 2010 and the Balance of Payment (as % of service exports) in Lithuania in 2012?
Give a very brief answer. -43.41. What is the difference between the Balance of Payment (as % of service exports) in Finland in 2010 and the Balance of Payment (as % of service exports) in Tanzania in 2012?
Your response must be concise. -8.08. What is the difference between the Balance of Payment (as % of service exports) of Ireland in 2010 and the Balance of Payment (as % of service exports) of Lithuania in 2012?
Give a very brief answer. -52.61. What is the difference between the Balance of Payment (as % of service exports) of Ireland in 2010 and the Balance of Payment (as % of service exports) of Tanzania in 2012?
Keep it short and to the point. -17.29. What is the difference between the Balance of Payment (as % of service exports) of Lithuania in 2010 and the Balance of Payment (as % of service exports) of Tanzania in 2012?
Make the answer very short. 31.13. What is the difference between the Balance of Payment (as % of service exports) of Finland in 2010 and the Balance of Payment (as % of service exports) of Ireland in 2013?
Give a very brief answer. 9.68. What is the difference between the Balance of Payment (as % of service exports) in Finland in 2010 and the Balance of Payment (as % of service exports) in Lithuania in 2013?
Your response must be concise. -46.56. What is the difference between the Balance of Payment (as % of service exports) in Finland in 2010 and the Balance of Payment (as % of service exports) in Tanzania in 2013?
Provide a succinct answer. -10.19. What is the difference between the Balance of Payment (as % of service exports) of Ireland in 2010 and the Balance of Payment (as % of service exports) of Lithuania in 2013?
Provide a succinct answer. -55.77. What is the difference between the Balance of Payment (as % of service exports) of Ireland in 2010 and the Balance of Payment (as % of service exports) of Tanzania in 2013?
Make the answer very short. -19.39. What is the difference between the Balance of Payment (as % of service exports) of Lithuania in 2010 and the Balance of Payment (as % of service exports) of Tanzania in 2013?
Your answer should be very brief. 29.03. What is the difference between the Balance of Payment (as % of service exports) in Finland in 2011 and the Balance of Payment (as % of service exports) in Ireland in 2012?
Make the answer very short. 8.6. What is the difference between the Balance of Payment (as % of service exports) of Finland in 2011 and the Balance of Payment (as % of service exports) of Lithuania in 2012?
Make the answer very short. -43.9. What is the difference between the Balance of Payment (as % of service exports) of Finland in 2011 and the Balance of Payment (as % of service exports) of Tanzania in 2012?
Your answer should be very brief. -8.57. What is the difference between the Balance of Payment (as % of service exports) in Ireland in 2011 and the Balance of Payment (as % of service exports) in Lithuania in 2012?
Provide a succinct answer. -52.17. What is the difference between the Balance of Payment (as % of service exports) of Ireland in 2011 and the Balance of Payment (as % of service exports) of Tanzania in 2012?
Offer a terse response. -16.85. What is the difference between the Balance of Payment (as % of service exports) in Lithuania in 2011 and the Balance of Payment (as % of service exports) in Tanzania in 2012?
Offer a very short reply. 32.57. What is the difference between the Balance of Payment (as % of service exports) in Finland in 2011 and the Balance of Payment (as % of service exports) in Ireland in 2013?
Give a very brief answer. 9.19. What is the difference between the Balance of Payment (as % of service exports) of Finland in 2011 and the Balance of Payment (as % of service exports) of Lithuania in 2013?
Keep it short and to the point. -47.06. What is the difference between the Balance of Payment (as % of service exports) of Finland in 2011 and the Balance of Payment (as % of service exports) of Tanzania in 2013?
Offer a terse response. -10.68. What is the difference between the Balance of Payment (as % of service exports) of Ireland in 2011 and the Balance of Payment (as % of service exports) of Lithuania in 2013?
Ensure brevity in your answer.  -55.33. What is the difference between the Balance of Payment (as % of service exports) in Ireland in 2011 and the Balance of Payment (as % of service exports) in Tanzania in 2013?
Make the answer very short. -18.96. What is the difference between the Balance of Payment (as % of service exports) of Lithuania in 2011 and the Balance of Payment (as % of service exports) of Tanzania in 2013?
Keep it short and to the point. 30.46. What is the difference between the Balance of Payment (as % of service exports) of Finland in 2012 and the Balance of Payment (as % of service exports) of Ireland in 2013?
Give a very brief answer. 7.81. What is the difference between the Balance of Payment (as % of service exports) of Finland in 2012 and the Balance of Payment (as % of service exports) of Lithuania in 2013?
Provide a short and direct response. -48.44. What is the difference between the Balance of Payment (as % of service exports) in Finland in 2012 and the Balance of Payment (as % of service exports) in Tanzania in 2013?
Your answer should be very brief. -12.06. What is the difference between the Balance of Payment (as % of service exports) in Ireland in 2012 and the Balance of Payment (as % of service exports) in Lithuania in 2013?
Offer a very short reply. -55.65. What is the difference between the Balance of Payment (as % of service exports) in Ireland in 2012 and the Balance of Payment (as % of service exports) in Tanzania in 2013?
Make the answer very short. -19.28. What is the difference between the Balance of Payment (as % of service exports) of Lithuania in 2012 and the Balance of Payment (as % of service exports) of Tanzania in 2013?
Offer a very short reply. 33.22. What is the average Balance of Payment (as % of service exports) of Finland per year?
Provide a succinct answer. 15.58. What is the average Balance of Payment (as % of service exports) of Ireland per year?
Offer a terse response. 5.15. What is the average Balance of Payment (as % of service exports) in Lithuania per year?
Your response must be concise. 55.8. What is the average Balance of Payment (as % of service exports) of Tanzania per year?
Offer a terse response. 21.2. In the year 2006, what is the difference between the Balance of Payment (as % of service exports) in Finland and Balance of Payment (as % of service exports) in Ireland?
Ensure brevity in your answer.  15.82. In the year 2006, what is the difference between the Balance of Payment (as % of service exports) in Finland and Balance of Payment (as % of service exports) in Lithuania?
Keep it short and to the point. -33.64. In the year 2006, what is the difference between the Balance of Payment (as % of service exports) in Finland and Balance of Payment (as % of service exports) in Tanzania?
Offer a terse response. -2.16. In the year 2006, what is the difference between the Balance of Payment (as % of service exports) in Ireland and Balance of Payment (as % of service exports) in Lithuania?
Your answer should be compact. -49.46. In the year 2006, what is the difference between the Balance of Payment (as % of service exports) of Ireland and Balance of Payment (as % of service exports) of Tanzania?
Ensure brevity in your answer.  -17.98. In the year 2006, what is the difference between the Balance of Payment (as % of service exports) of Lithuania and Balance of Payment (as % of service exports) of Tanzania?
Your response must be concise. 31.48. In the year 2007, what is the difference between the Balance of Payment (as % of service exports) in Finland and Balance of Payment (as % of service exports) in Ireland?
Offer a terse response. 15.82. In the year 2007, what is the difference between the Balance of Payment (as % of service exports) in Finland and Balance of Payment (as % of service exports) in Lithuania?
Keep it short and to the point. -34.89. In the year 2007, what is the difference between the Balance of Payment (as % of service exports) in Finland and Balance of Payment (as % of service exports) in Tanzania?
Provide a short and direct response. 3.03. In the year 2007, what is the difference between the Balance of Payment (as % of service exports) of Ireland and Balance of Payment (as % of service exports) of Lithuania?
Offer a very short reply. -50.71. In the year 2007, what is the difference between the Balance of Payment (as % of service exports) in Ireland and Balance of Payment (as % of service exports) in Tanzania?
Your answer should be compact. -12.79. In the year 2007, what is the difference between the Balance of Payment (as % of service exports) of Lithuania and Balance of Payment (as % of service exports) of Tanzania?
Make the answer very short. 37.92. In the year 2008, what is the difference between the Balance of Payment (as % of service exports) in Finland and Balance of Payment (as % of service exports) in Ireland?
Your answer should be compact. 10.4. In the year 2008, what is the difference between the Balance of Payment (as % of service exports) of Finland and Balance of Payment (as % of service exports) of Lithuania?
Make the answer very short. -41.62. In the year 2008, what is the difference between the Balance of Payment (as % of service exports) in Finland and Balance of Payment (as % of service exports) in Tanzania?
Your answer should be compact. -2.83. In the year 2008, what is the difference between the Balance of Payment (as % of service exports) in Ireland and Balance of Payment (as % of service exports) in Lithuania?
Keep it short and to the point. -52.02. In the year 2008, what is the difference between the Balance of Payment (as % of service exports) of Ireland and Balance of Payment (as % of service exports) of Tanzania?
Ensure brevity in your answer.  -13.23. In the year 2008, what is the difference between the Balance of Payment (as % of service exports) of Lithuania and Balance of Payment (as % of service exports) of Tanzania?
Your response must be concise. 38.79. In the year 2009, what is the difference between the Balance of Payment (as % of service exports) of Finland and Balance of Payment (as % of service exports) of Ireland?
Provide a succinct answer. 8.29. In the year 2009, what is the difference between the Balance of Payment (as % of service exports) in Finland and Balance of Payment (as % of service exports) in Lithuania?
Provide a succinct answer. -38.12. In the year 2009, what is the difference between the Balance of Payment (as % of service exports) in Finland and Balance of Payment (as % of service exports) in Tanzania?
Offer a terse response. -4.67. In the year 2009, what is the difference between the Balance of Payment (as % of service exports) of Ireland and Balance of Payment (as % of service exports) of Lithuania?
Offer a terse response. -46.41. In the year 2009, what is the difference between the Balance of Payment (as % of service exports) of Ireland and Balance of Payment (as % of service exports) of Tanzania?
Ensure brevity in your answer.  -12.96. In the year 2009, what is the difference between the Balance of Payment (as % of service exports) in Lithuania and Balance of Payment (as % of service exports) in Tanzania?
Make the answer very short. 33.45. In the year 2010, what is the difference between the Balance of Payment (as % of service exports) in Finland and Balance of Payment (as % of service exports) in Ireland?
Your answer should be very brief. 9.2. In the year 2010, what is the difference between the Balance of Payment (as % of service exports) of Finland and Balance of Payment (as % of service exports) of Lithuania?
Your answer should be compact. -39.21. In the year 2010, what is the difference between the Balance of Payment (as % of service exports) in Finland and Balance of Payment (as % of service exports) in Tanzania?
Make the answer very short. -7.17. In the year 2010, what is the difference between the Balance of Payment (as % of service exports) of Ireland and Balance of Payment (as % of service exports) of Lithuania?
Give a very brief answer. -48.42. In the year 2010, what is the difference between the Balance of Payment (as % of service exports) of Ireland and Balance of Payment (as % of service exports) of Tanzania?
Make the answer very short. -16.37. In the year 2010, what is the difference between the Balance of Payment (as % of service exports) of Lithuania and Balance of Payment (as % of service exports) of Tanzania?
Offer a terse response. 32.04. In the year 2011, what is the difference between the Balance of Payment (as % of service exports) in Finland and Balance of Payment (as % of service exports) in Ireland?
Give a very brief answer. 8.28. In the year 2011, what is the difference between the Balance of Payment (as % of service exports) of Finland and Balance of Payment (as % of service exports) of Lithuania?
Offer a very short reply. -41.14. In the year 2011, what is the difference between the Balance of Payment (as % of service exports) in Finland and Balance of Payment (as % of service exports) in Tanzania?
Provide a short and direct response. -9.74. In the year 2011, what is the difference between the Balance of Payment (as % of service exports) of Ireland and Balance of Payment (as % of service exports) of Lithuania?
Your answer should be very brief. -49.42. In the year 2011, what is the difference between the Balance of Payment (as % of service exports) in Ireland and Balance of Payment (as % of service exports) in Tanzania?
Give a very brief answer. -18.02. In the year 2011, what is the difference between the Balance of Payment (as % of service exports) of Lithuania and Balance of Payment (as % of service exports) of Tanzania?
Provide a short and direct response. 31.4. In the year 2012, what is the difference between the Balance of Payment (as % of service exports) in Finland and Balance of Payment (as % of service exports) in Ireland?
Your answer should be very brief. 7.22. In the year 2012, what is the difference between the Balance of Payment (as % of service exports) in Finland and Balance of Payment (as % of service exports) in Lithuania?
Offer a terse response. -45.28. In the year 2012, what is the difference between the Balance of Payment (as % of service exports) in Finland and Balance of Payment (as % of service exports) in Tanzania?
Ensure brevity in your answer.  -9.96. In the year 2012, what is the difference between the Balance of Payment (as % of service exports) in Ireland and Balance of Payment (as % of service exports) in Lithuania?
Keep it short and to the point. -52.5. In the year 2012, what is the difference between the Balance of Payment (as % of service exports) of Ireland and Balance of Payment (as % of service exports) of Tanzania?
Provide a succinct answer. -17.17. In the year 2012, what is the difference between the Balance of Payment (as % of service exports) of Lithuania and Balance of Payment (as % of service exports) of Tanzania?
Your answer should be compact. 35.32. In the year 2013, what is the difference between the Balance of Payment (as % of service exports) in Finland and Balance of Payment (as % of service exports) in Ireland?
Offer a very short reply. 8.4. In the year 2013, what is the difference between the Balance of Payment (as % of service exports) in Finland and Balance of Payment (as % of service exports) in Lithuania?
Your response must be concise. -47.84. In the year 2013, what is the difference between the Balance of Payment (as % of service exports) in Finland and Balance of Payment (as % of service exports) in Tanzania?
Your answer should be compact. -11.47. In the year 2013, what is the difference between the Balance of Payment (as % of service exports) in Ireland and Balance of Payment (as % of service exports) in Lithuania?
Your answer should be compact. -56.25. In the year 2013, what is the difference between the Balance of Payment (as % of service exports) in Ireland and Balance of Payment (as % of service exports) in Tanzania?
Give a very brief answer. -19.87. In the year 2013, what is the difference between the Balance of Payment (as % of service exports) of Lithuania and Balance of Payment (as % of service exports) of Tanzania?
Ensure brevity in your answer.  36.38. What is the ratio of the Balance of Payment (as % of service exports) in Finland in 2006 to that in 2007?
Give a very brief answer. 0.98. What is the ratio of the Balance of Payment (as % of service exports) of Ireland in 2006 to that in 2007?
Make the answer very short. 0.92. What is the ratio of the Balance of Payment (as % of service exports) in Lithuania in 2006 to that in 2007?
Provide a short and direct response. 0.97. What is the ratio of the Balance of Payment (as % of service exports) in Tanzania in 2006 to that in 2007?
Provide a succinct answer. 1.27. What is the ratio of the Balance of Payment (as % of service exports) in Finland in 2006 to that in 2008?
Your answer should be very brief. 1.32. What is the ratio of the Balance of Payment (as % of service exports) in Ireland in 2006 to that in 2008?
Provide a succinct answer. 0.9. What is the ratio of the Balance of Payment (as % of service exports) of Lithuania in 2006 to that in 2008?
Offer a very short reply. 0.95. What is the ratio of the Balance of Payment (as % of service exports) in Tanzania in 2006 to that in 2008?
Give a very brief answer. 1.23. What is the ratio of the Balance of Payment (as % of service exports) in Finland in 2006 to that in 2009?
Your answer should be compact. 1.52. What is the ratio of the Balance of Payment (as % of service exports) of Ireland in 2006 to that in 2009?
Your response must be concise. 0.89. What is the ratio of the Balance of Payment (as % of service exports) of Lithuania in 2006 to that in 2009?
Your response must be concise. 1.05. What is the ratio of the Balance of Payment (as % of service exports) of Tanzania in 2006 to that in 2009?
Make the answer very short. 1.25. What is the ratio of the Balance of Payment (as % of service exports) of Finland in 2006 to that in 2010?
Keep it short and to the point. 1.39. What is the ratio of the Balance of Payment (as % of service exports) in Ireland in 2006 to that in 2010?
Provide a short and direct response. 0.84. What is the ratio of the Balance of Payment (as % of service exports) of Tanzania in 2006 to that in 2010?
Give a very brief answer. 1.03. What is the ratio of the Balance of Payment (as % of service exports) of Finland in 2006 to that in 2011?
Your answer should be very brief. 1.44. What is the ratio of the Balance of Payment (as % of service exports) of Ireland in 2006 to that in 2011?
Ensure brevity in your answer.  0.77. What is the ratio of the Balance of Payment (as % of service exports) of Lithuania in 2006 to that in 2011?
Provide a succinct answer. 0.98. What is the ratio of the Balance of Payment (as % of service exports) of Tanzania in 2006 to that in 2011?
Provide a short and direct response. 0.94. What is the ratio of the Balance of Payment (as % of service exports) of Finland in 2006 to that in 2012?
Your answer should be compact. 1.6. What is the ratio of the Balance of Payment (as % of service exports) of Ireland in 2006 to that in 2012?
Give a very brief answer. 0.82. What is the ratio of the Balance of Payment (as % of service exports) in Lithuania in 2006 to that in 2012?
Offer a very short reply. 0.93. What is the ratio of the Balance of Payment (as % of service exports) of Finland in 2006 to that in 2013?
Your answer should be very brief. 1.53. What is the ratio of the Balance of Payment (as % of service exports) of Ireland in 2006 to that in 2013?
Make the answer very short. 0.92. What is the ratio of the Balance of Payment (as % of service exports) in Lithuania in 2006 to that in 2013?
Your answer should be compact. 0.88. What is the ratio of the Balance of Payment (as % of service exports) of Tanzania in 2006 to that in 2013?
Provide a succinct answer. 0.91. What is the ratio of the Balance of Payment (as % of service exports) of Finland in 2007 to that in 2008?
Offer a very short reply. 1.34. What is the ratio of the Balance of Payment (as % of service exports) in Ireland in 2007 to that in 2008?
Offer a very short reply. 0.98. What is the ratio of the Balance of Payment (as % of service exports) of Lithuania in 2007 to that in 2008?
Your answer should be very brief. 0.98. What is the ratio of the Balance of Payment (as % of service exports) in Tanzania in 2007 to that in 2008?
Your answer should be compact. 0.97. What is the ratio of the Balance of Payment (as % of service exports) of Finland in 2007 to that in 2009?
Ensure brevity in your answer.  1.55. What is the ratio of the Balance of Payment (as % of service exports) of Lithuania in 2007 to that in 2009?
Your response must be concise. 1.08. What is the ratio of the Balance of Payment (as % of service exports) of Tanzania in 2007 to that in 2009?
Provide a succinct answer. 0.98. What is the ratio of the Balance of Payment (as % of service exports) in Finland in 2007 to that in 2010?
Ensure brevity in your answer.  1.42. What is the ratio of the Balance of Payment (as % of service exports) in Ireland in 2007 to that in 2010?
Provide a short and direct response. 0.91. What is the ratio of the Balance of Payment (as % of service exports) of Lithuania in 2007 to that in 2010?
Provide a short and direct response. 1.03. What is the ratio of the Balance of Payment (as % of service exports) in Tanzania in 2007 to that in 2010?
Offer a terse response. 0.81. What is the ratio of the Balance of Payment (as % of service exports) in Finland in 2007 to that in 2011?
Your response must be concise. 1.47. What is the ratio of the Balance of Payment (as % of service exports) in Ireland in 2007 to that in 2011?
Provide a succinct answer. 0.84. What is the ratio of the Balance of Payment (as % of service exports) in Tanzania in 2007 to that in 2011?
Your response must be concise. 0.74. What is the ratio of the Balance of Payment (as % of service exports) in Finland in 2007 to that in 2012?
Keep it short and to the point. 1.63. What is the ratio of the Balance of Payment (as % of service exports) of Ireland in 2007 to that in 2012?
Your answer should be very brief. 0.89. What is the ratio of the Balance of Payment (as % of service exports) in Lithuania in 2007 to that in 2012?
Keep it short and to the point. 0.96. What is the ratio of the Balance of Payment (as % of service exports) of Tanzania in 2007 to that in 2012?
Make the answer very short. 0.78. What is the ratio of the Balance of Payment (as % of service exports) in Finland in 2007 to that in 2013?
Ensure brevity in your answer.  1.55. What is the ratio of the Balance of Payment (as % of service exports) of Ireland in 2007 to that in 2013?
Your answer should be very brief. 1. What is the ratio of the Balance of Payment (as % of service exports) in Lithuania in 2007 to that in 2013?
Offer a very short reply. 0.91. What is the ratio of the Balance of Payment (as % of service exports) of Tanzania in 2007 to that in 2013?
Offer a terse response. 0.71. What is the ratio of the Balance of Payment (as % of service exports) of Finland in 2008 to that in 2009?
Offer a terse response. 1.15. What is the ratio of the Balance of Payment (as % of service exports) in Lithuania in 2008 to that in 2009?
Your answer should be compact. 1.11. What is the ratio of the Balance of Payment (as % of service exports) of Tanzania in 2008 to that in 2009?
Provide a short and direct response. 1.01. What is the ratio of the Balance of Payment (as % of service exports) in Finland in 2008 to that in 2010?
Make the answer very short. 1.05. What is the ratio of the Balance of Payment (as % of service exports) in Ireland in 2008 to that in 2010?
Your response must be concise. 0.93. What is the ratio of the Balance of Payment (as % of service exports) in Lithuania in 2008 to that in 2010?
Ensure brevity in your answer.  1.06. What is the ratio of the Balance of Payment (as % of service exports) in Tanzania in 2008 to that in 2010?
Make the answer very short. 0.84. What is the ratio of the Balance of Payment (as % of service exports) of Finland in 2008 to that in 2011?
Keep it short and to the point. 1.09. What is the ratio of the Balance of Payment (as % of service exports) of Ireland in 2008 to that in 2011?
Your answer should be compact. 0.86. What is the ratio of the Balance of Payment (as % of service exports) of Lithuania in 2008 to that in 2011?
Provide a short and direct response. 1.03. What is the ratio of the Balance of Payment (as % of service exports) of Tanzania in 2008 to that in 2011?
Provide a succinct answer. 0.76. What is the ratio of the Balance of Payment (as % of service exports) in Finland in 2008 to that in 2012?
Offer a very short reply. 1.21. What is the ratio of the Balance of Payment (as % of service exports) of Ireland in 2008 to that in 2012?
Your response must be concise. 0.91. What is the ratio of the Balance of Payment (as % of service exports) in Lithuania in 2008 to that in 2012?
Ensure brevity in your answer.  0.98. What is the ratio of the Balance of Payment (as % of service exports) in Tanzania in 2008 to that in 2012?
Your answer should be compact. 0.8. What is the ratio of the Balance of Payment (as % of service exports) of Finland in 2008 to that in 2013?
Offer a very short reply. 1.16. What is the ratio of the Balance of Payment (as % of service exports) of Ireland in 2008 to that in 2013?
Offer a very short reply. 1.02. What is the ratio of the Balance of Payment (as % of service exports) in Lithuania in 2008 to that in 2013?
Make the answer very short. 0.93. What is the ratio of the Balance of Payment (as % of service exports) in Tanzania in 2008 to that in 2013?
Your response must be concise. 0.74. What is the ratio of the Balance of Payment (as % of service exports) of Finland in 2009 to that in 2010?
Your response must be concise. 0.91. What is the ratio of the Balance of Payment (as % of service exports) of Ireland in 2009 to that in 2010?
Make the answer very short. 0.94. What is the ratio of the Balance of Payment (as % of service exports) in Lithuania in 2009 to that in 2010?
Offer a very short reply. 0.96. What is the ratio of the Balance of Payment (as % of service exports) in Tanzania in 2009 to that in 2010?
Offer a very short reply. 0.83. What is the ratio of the Balance of Payment (as % of service exports) in Finland in 2009 to that in 2011?
Your response must be concise. 0.95. What is the ratio of the Balance of Payment (as % of service exports) in Ireland in 2009 to that in 2011?
Keep it short and to the point. 0.87. What is the ratio of the Balance of Payment (as % of service exports) in Lithuania in 2009 to that in 2011?
Offer a very short reply. 0.93. What is the ratio of the Balance of Payment (as % of service exports) of Tanzania in 2009 to that in 2011?
Make the answer very short. 0.76. What is the ratio of the Balance of Payment (as % of service exports) in Finland in 2009 to that in 2012?
Offer a very short reply. 1.05. What is the ratio of the Balance of Payment (as % of service exports) in Ireland in 2009 to that in 2012?
Your answer should be compact. 0.92. What is the ratio of the Balance of Payment (as % of service exports) in Lithuania in 2009 to that in 2012?
Your answer should be compact. 0.89. What is the ratio of the Balance of Payment (as % of service exports) in Tanzania in 2009 to that in 2012?
Provide a short and direct response. 0.79. What is the ratio of the Balance of Payment (as % of service exports) of Lithuania in 2009 to that in 2013?
Your answer should be very brief. 0.84. What is the ratio of the Balance of Payment (as % of service exports) in Tanzania in 2009 to that in 2013?
Keep it short and to the point. 0.73. What is the ratio of the Balance of Payment (as % of service exports) in Finland in 2010 to that in 2011?
Offer a terse response. 1.03. What is the ratio of the Balance of Payment (as % of service exports) of Ireland in 2010 to that in 2011?
Provide a short and direct response. 0.93. What is the ratio of the Balance of Payment (as % of service exports) in Tanzania in 2010 to that in 2011?
Provide a short and direct response. 0.91. What is the ratio of the Balance of Payment (as % of service exports) in Finland in 2010 to that in 2012?
Give a very brief answer. 1.15. What is the ratio of the Balance of Payment (as % of service exports) in Ireland in 2010 to that in 2012?
Give a very brief answer. 0.98. What is the ratio of the Balance of Payment (as % of service exports) in Lithuania in 2010 to that in 2012?
Your answer should be very brief. 0.93. What is the ratio of the Balance of Payment (as % of service exports) in Tanzania in 2010 to that in 2012?
Offer a very short reply. 0.96. What is the ratio of the Balance of Payment (as % of service exports) in Finland in 2010 to that in 2013?
Your answer should be very brief. 1.1. What is the ratio of the Balance of Payment (as % of service exports) in Ireland in 2010 to that in 2013?
Keep it short and to the point. 1.1. What is the ratio of the Balance of Payment (as % of service exports) in Lithuania in 2010 to that in 2013?
Provide a succinct answer. 0.88. What is the ratio of the Balance of Payment (as % of service exports) in Tanzania in 2010 to that in 2013?
Give a very brief answer. 0.88. What is the ratio of the Balance of Payment (as % of service exports) of Finland in 2011 to that in 2012?
Make the answer very short. 1.11. What is the ratio of the Balance of Payment (as % of service exports) of Ireland in 2011 to that in 2012?
Ensure brevity in your answer.  1.06. What is the ratio of the Balance of Payment (as % of service exports) in Lithuania in 2011 to that in 2012?
Your answer should be very brief. 0.95. What is the ratio of the Balance of Payment (as % of service exports) in Tanzania in 2011 to that in 2012?
Your answer should be very brief. 1.05. What is the ratio of the Balance of Payment (as % of service exports) of Finland in 2011 to that in 2013?
Your answer should be compact. 1.06. What is the ratio of the Balance of Payment (as % of service exports) of Ireland in 2011 to that in 2013?
Make the answer very short. 1.19. What is the ratio of the Balance of Payment (as % of service exports) of Lithuania in 2011 to that in 2013?
Your answer should be compact. 0.9. What is the ratio of the Balance of Payment (as % of service exports) in Tanzania in 2011 to that in 2013?
Provide a short and direct response. 0.96. What is the ratio of the Balance of Payment (as % of service exports) in Finland in 2012 to that in 2013?
Offer a terse response. 0.96. What is the ratio of the Balance of Payment (as % of service exports) of Ireland in 2012 to that in 2013?
Give a very brief answer. 1.12. What is the ratio of the Balance of Payment (as % of service exports) in Lithuania in 2012 to that in 2013?
Keep it short and to the point. 0.95. What is the ratio of the Balance of Payment (as % of service exports) of Tanzania in 2012 to that in 2013?
Give a very brief answer. 0.92. What is the difference between the highest and the second highest Balance of Payment (as % of service exports) in Finland?
Your response must be concise. 0.39. What is the difference between the highest and the second highest Balance of Payment (as % of service exports) of Ireland?
Your answer should be very brief. 0.32. What is the difference between the highest and the second highest Balance of Payment (as % of service exports) of Lithuania?
Offer a very short reply. 3.16. What is the difference between the highest and the second highest Balance of Payment (as % of service exports) in Tanzania?
Your response must be concise. 0.94. What is the difference between the highest and the lowest Balance of Payment (as % of service exports) in Finland?
Your answer should be very brief. 7.99. What is the difference between the highest and the lowest Balance of Payment (as % of service exports) of Ireland?
Give a very brief answer. 1.33. What is the difference between the highest and the lowest Balance of Payment (as % of service exports) of Lithuania?
Keep it short and to the point. 9.7. What is the difference between the highest and the lowest Balance of Payment (as % of service exports) in Tanzania?
Keep it short and to the point. 7.1. 